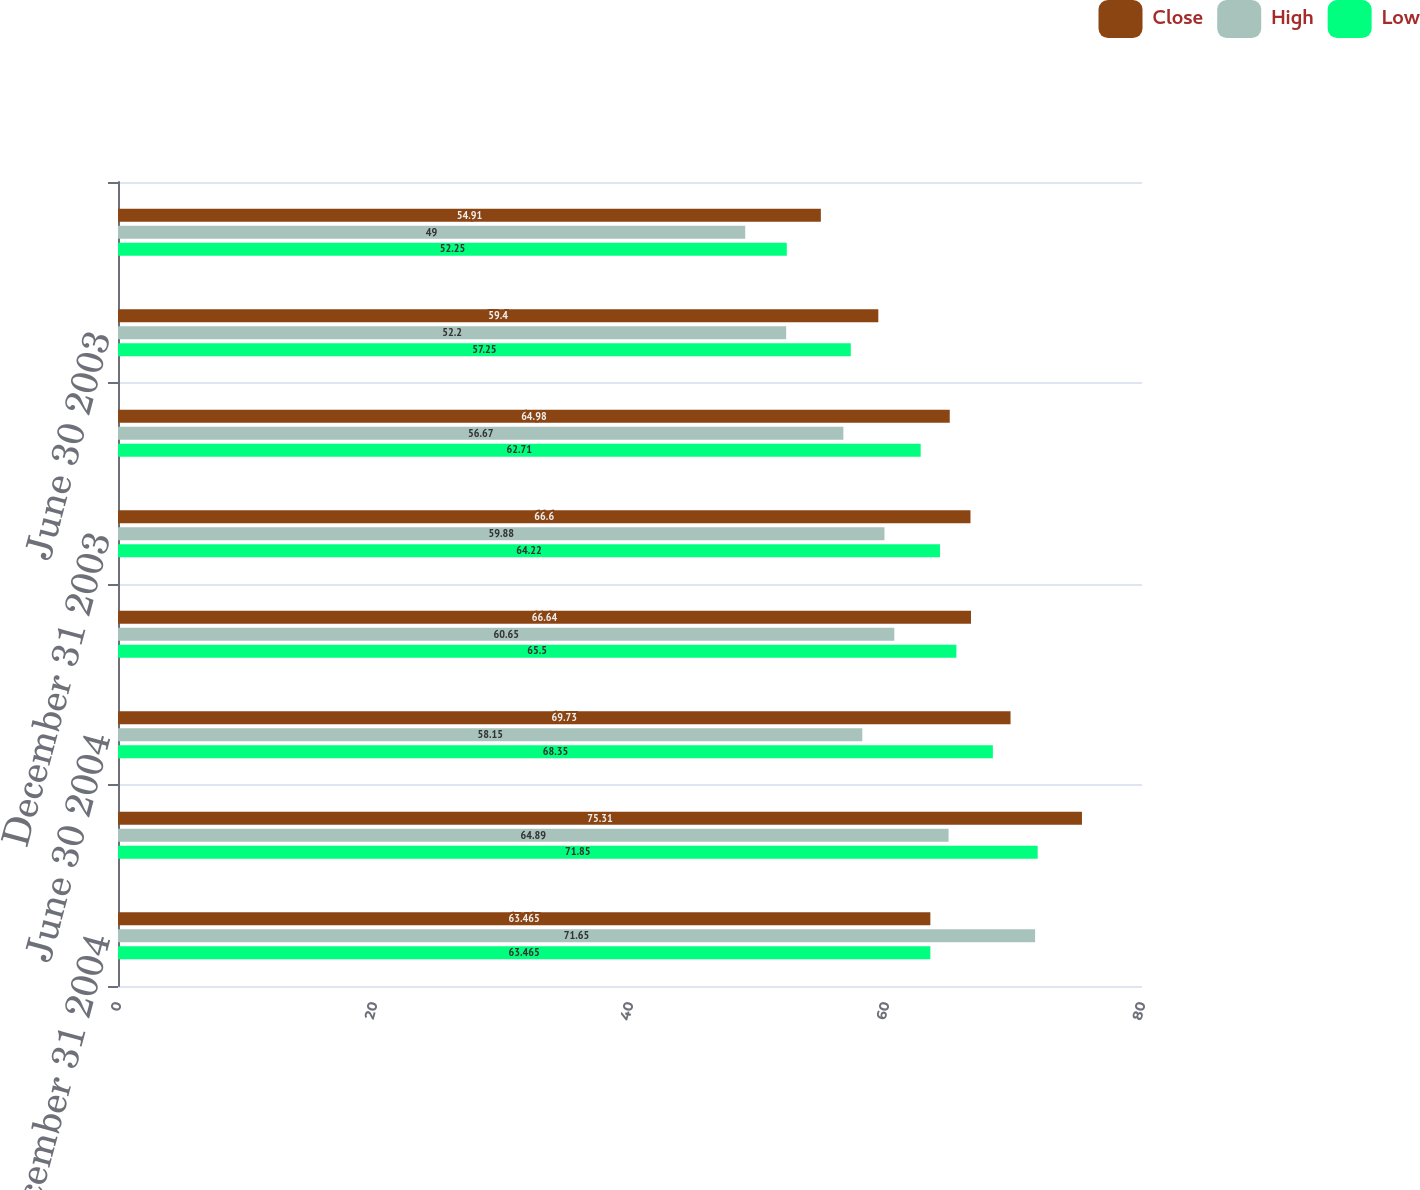<chart> <loc_0><loc_0><loc_500><loc_500><stacked_bar_chart><ecel><fcel>December 31 2004<fcel>September 30 2004<fcel>June 30 2004<fcel>March 31 2004<fcel>December 31 2003<fcel>September 30 2003<fcel>June 30 2003<fcel>March 31 2003<nl><fcel>Close<fcel>63.465<fcel>75.31<fcel>69.73<fcel>66.64<fcel>66.6<fcel>64.98<fcel>59.4<fcel>54.91<nl><fcel>High<fcel>71.65<fcel>64.89<fcel>58.15<fcel>60.65<fcel>59.88<fcel>56.67<fcel>52.2<fcel>49<nl><fcel>Low<fcel>63.465<fcel>71.85<fcel>68.35<fcel>65.5<fcel>64.22<fcel>62.71<fcel>57.25<fcel>52.25<nl></chart> 